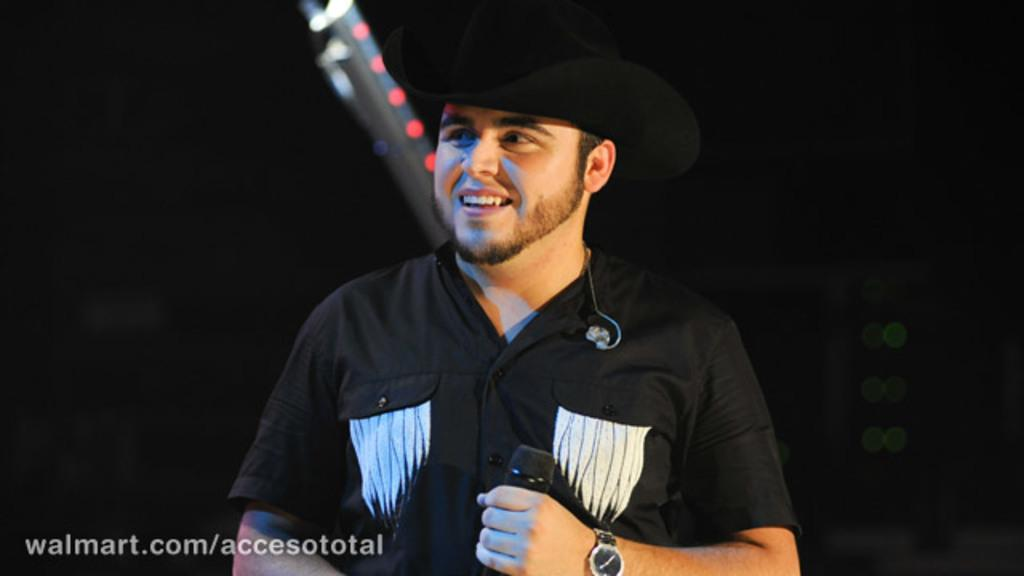What is the main subject of the image? The main subject of the image is a man. What is the man doing in the image? The man is standing in the image. What is the man wearing on his upper body? The man is wearing a black t-shirt. What type of headwear is the man wearing? The man is wearing a hat. What accessory is the man wearing on his wrist? The man is wearing a wristwatch. What object is the man holding in his hand? The man is holding a mic in his hand. What type of poison is the man holding in his hand? The man is not holding any poison in his hand; he is holding a mic. Is there a doll present in the image? There is no mention of a doll in the provided facts, so it cannot be determined if one is present in the image. 